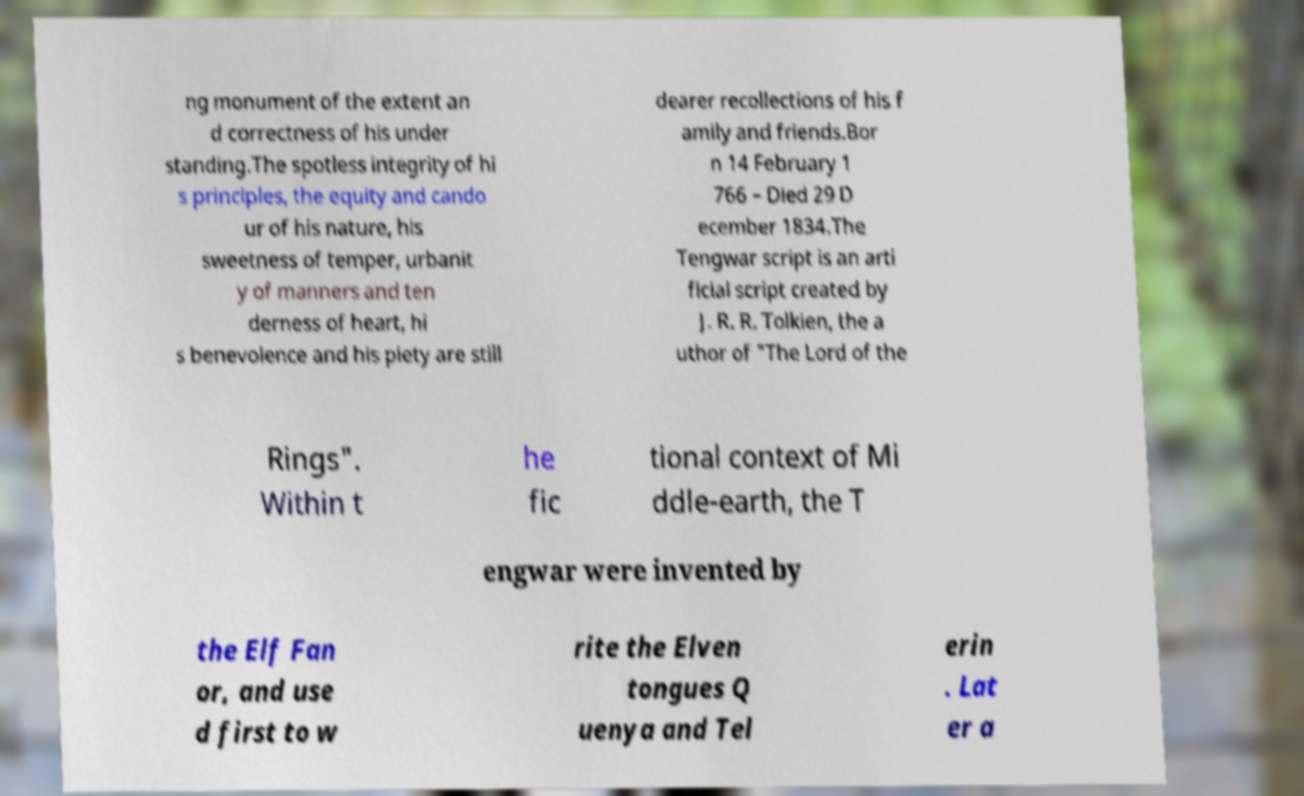Can you accurately transcribe the text from the provided image for me? ng monument of the extent an d correctness of his under standing.The spotless integrity of hi s principles, the equity and cando ur of his nature, his sweetness of temper, urbanit y of manners and ten derness of heart, hi s benevolence and his piety are still dearer recollections of his f amily and friends.Bor n 14 February 1 766 – Died 29 D ecember 1834.The Tengwar script is an arti ficial script created by J. R. R. Tolkien, the a uthor of "The Lord of the Rings". Within t he fic tional context of Mi ddle-earth, the T engwar were invented by the Elf Fan or, and use d first to w rite the Elven tongues Q uenya and Tel erin . Lat er a 